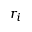Convert formula to latex. <formula><loc_0><loc_0><loc_500><loc_500>r _ { i }</formula> 